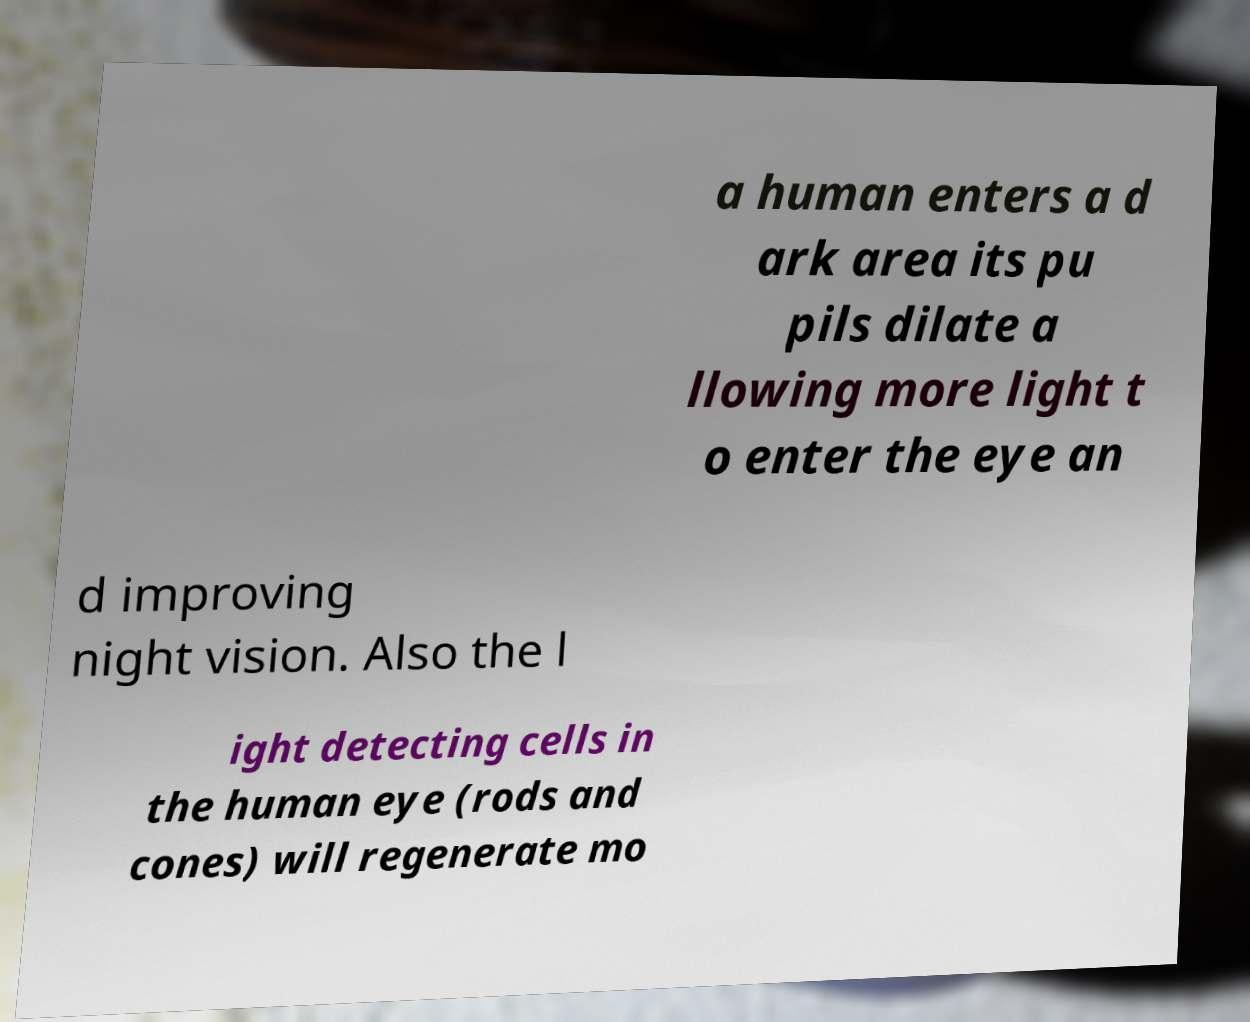Please read and relay the text visible in this image. What does it say? a human enters a d ark area its pu pils dilate a llowing more light t o enter the eye an d improving night vision. Also the l ight detecting cells in the human eye (rods and cones) will regenerate mo 